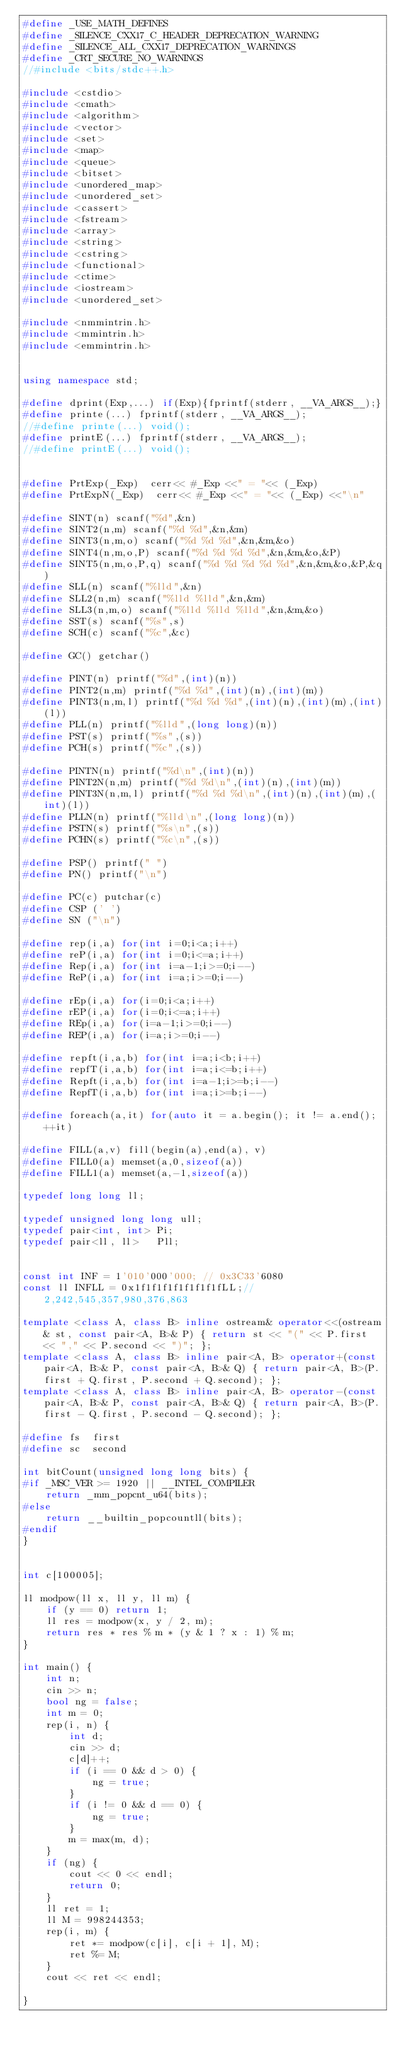<code> <loc_0><loc_0><loc_500><loc_500><_C++_>#define _USE_MATH_DEFINES
#define _SILENCE_CXX17_C_HEADER_DEPRECATION_WARNING
#define _SILENCE_ALL_CXX17_DEPRECATION_WARNINGS
#define _CRT_SECURE_NO_WARNINGS
//#include <bits/stdc++.h>

#include <cstdio>
#include <cmath>
#include <algorithm>
#include <vector>
#include <set>
#include <map>
#include <queue>
#include <bitset>
#include <unordered_map>
#include <unordered_set>
#include <cassert>
#include <fstream>
#include <array>
#include <string>
#include <cstring>
#include <functional>
#include <ctime>
#include <iostream>
#include <unordered_set>

#include <nmmintrin.h>
#include <mmintrin.h>
#include <emmintrin.h>


using namespace std;

#define dprint(Exp,...) if(Exp){fprintf(stderr, __VA_ARGS__);}
#define printe(...) fprintf(stderr, __VA_ARGS__);
//#define printe(...) void();
#define printE(...) fprintf(stderr, __VA_ARGS__);
//#define printE(...) void();


#define PrtExp(_Exp)  cerr<< #_Exp <<" = "<< (_Exp)
#define PrtExpN(_Exp)  cerr<< #_Exp <<" = "<< (_Exp) <<"\n"

#define SINT(n) scanf("%d",&n)
#define SINT2(n,m) scanf("%d %d",&n,&m)
#define SINT3(n,m,o) scanf("%d %d %d",&n,&m,&o)
#define SINT4(n,m,o,P) scanf("%d %d %d %d",&n,&m,&o,&P)
#define SINT5(n,m,o,P,q) scanf("%d %d %d %d %d",&n,&m,&o,&P,&q)
#define SLL(n) scanf("%lld",&n)
#define SLL2(n,m) scanf("%lld %lld",&n,&m)
#define SLL3(n,m,o) scanf("%lld %lld %lld",&n,&m,&o)
#define SST(s) scanf("%s",s)
#define SCH(c) scanf("%c",&c)

#define GC() getchar()

#define PINT(n) printf("%d",(int)(n))
#define PINT2(n,m) printf("%d %d",(int)(n),(int)(m))
#define PINT3(n,m,l) printf("%d %d %d",(int)(n),(int)(m),(int)(l))
#define PLL(n) printf("%lld",(long long)(n))
#define PST(s) printf("%s",(s))
#define PCH(s) printf("%c",(s))

#define PINTN(n) printf("%d\n",(int)(n))
#define PINT2N(n,m) printf("%d %d\n",(int)(n),(int)(m))
#define PINT3N(n,m,l) printf("%d %d %d\n",(int)(n),(int)(m),(int)(l))
#define PLLN(n) printf("%lld\n",(long long)(n))
#define PSTN(s) printf("%s\n",(s))
#define PCHN(s) printf("%c\n",(s))

#define PSP() printf(" ")
#define PN() printf("\n")

#define PC(c) putchar(c)
#define CSP (' ')
#define SN ("\n")

#define rep(i,a) for(int i=0;i<a;i++)
#define reP(i,a) for(int i=0;i<=a;i++)
#define Rep(i,a) for(int i=a-1;i>=0;i--)
#define ReP(i,a) for(int i=a;i>=0;i--)

#define rEp(i,a) for(i=0;i<a;i++)
#define rEP(i,a) for(i=0;i<=a;i++)
#define REp(i,a) for(i=a-1;i>=0;i--)
#define REP(i,a) for(i=a;i>=0;i--)

#define repft(i,a,b) for(int i=a;i<b;i++)
#define repfT(i,a,b) for(int i=a;i<=b;i++)
#define Repft(i,a,b) for(int i=a-1;i>=b;i--)
#define RepfT(i,a,b) for(int i=a;i>=b;i--)

#define foreach(a,it) for(auto it = a.begin(); it != a.end(); ++it)

#define FILL(a,v) fill(begin(a),end(a), v)
#define FILL0(a) memset(a,0,sizeof(a))
#define FILL1(a) memset(a,-1,sizeof(a))

typedef long long ll;

typedef unsigned long long ull;
typedef pair<int, int> Pi;
typedef pair<ll, ll>   Pll;


const int INF = 1'010'000'000; // 0x3C33'6080
const ll INFLL = 0x1f1f1f1f1f1f1f1fLL;//2,242,545,357,980,376,863

template <class A, class B> inline ostream& operator<<(ostream& st, const pair<A, B>& P) { return st << "(" << P.first << "," << P.second << ")"; };
template <class A, class B> inline pair<A, B> operator+(const pair<A, B>& P, const pair<A, B>& Q) { return pair<A, B>(P.first + Q.first, P.second + Q.second); };
template <class A, class B> inline pair<A, B> operator-(const pair<A, B>& P, const pair<A, B>& Q) { return pair<A, B>(P.first - Q.first, P.second - Q.second); };

#define fs  first
#define sc  second

int bitCount(unsigned long long bits) {
#if _MSC_VER >= 1920 || __INTEL_COMPILER
	return _mm_popcnt_u64(bits);
#else
	return __builtin_popcountll(bits);
#endif 
}


int c[100005];

ll modpow(ll x, ll y, ll m) {
	if (y == 0) return 1;
	ll res = modpow(x, y / 2, m);
	return res * res % m * (y & 1 ? x : 1) % m;
}

int main() {
	int n;
	cin >> n;
	bool ng = false;
	int m = 0;
	rep(i, n) {
		int d;
		cin >> d;
		c[d]++;
		if (i == 0 && d > 0) {
			ng = true;
		}
		if (i != 0 && d == 0) {
			ng = true;
		}
		m = max(m, d);
	}
	if (ng) {
		cout << 0 << endl;
		return 0;
	}
	ll ret = 1;
	ll M = 998244353;
	rep(i, m) {
		ret *= modpow(c[i], c[i + 1], M);
		ret %= M;
	}
	cout << ret << endl;

}
</code> 